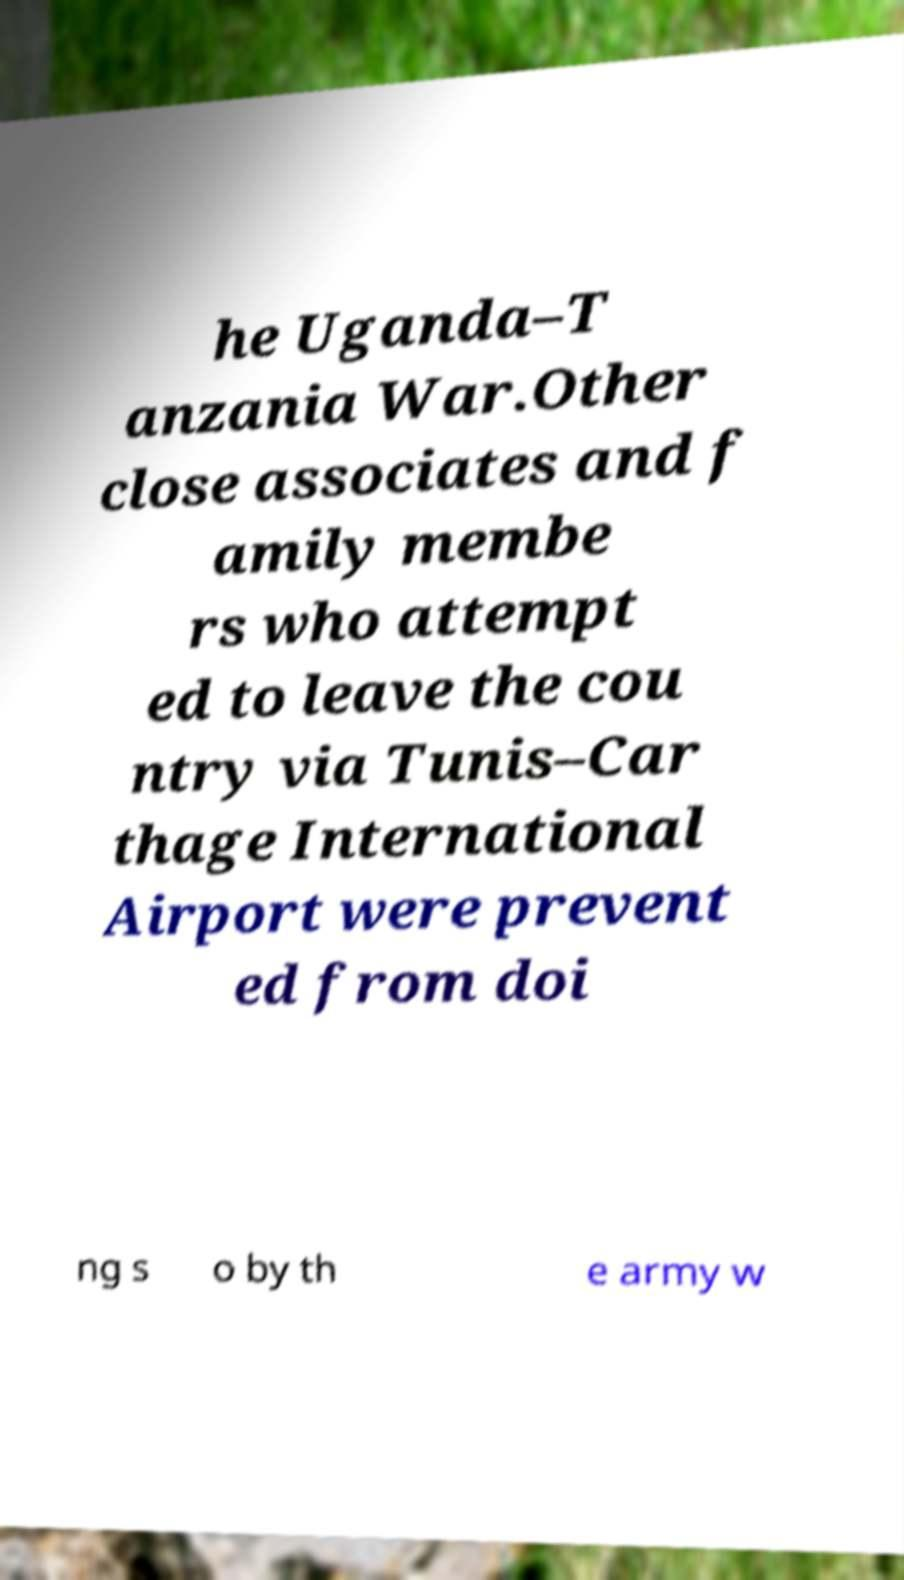I need the written content from this picture converted into text. Can you do that? he Uganda–T anzania War.Other close associates and f amily membe rs who attempt ed to leave the cou ntry via Tunis–Car thage International Airport were prevent ed from doi ng s o by th e army w 